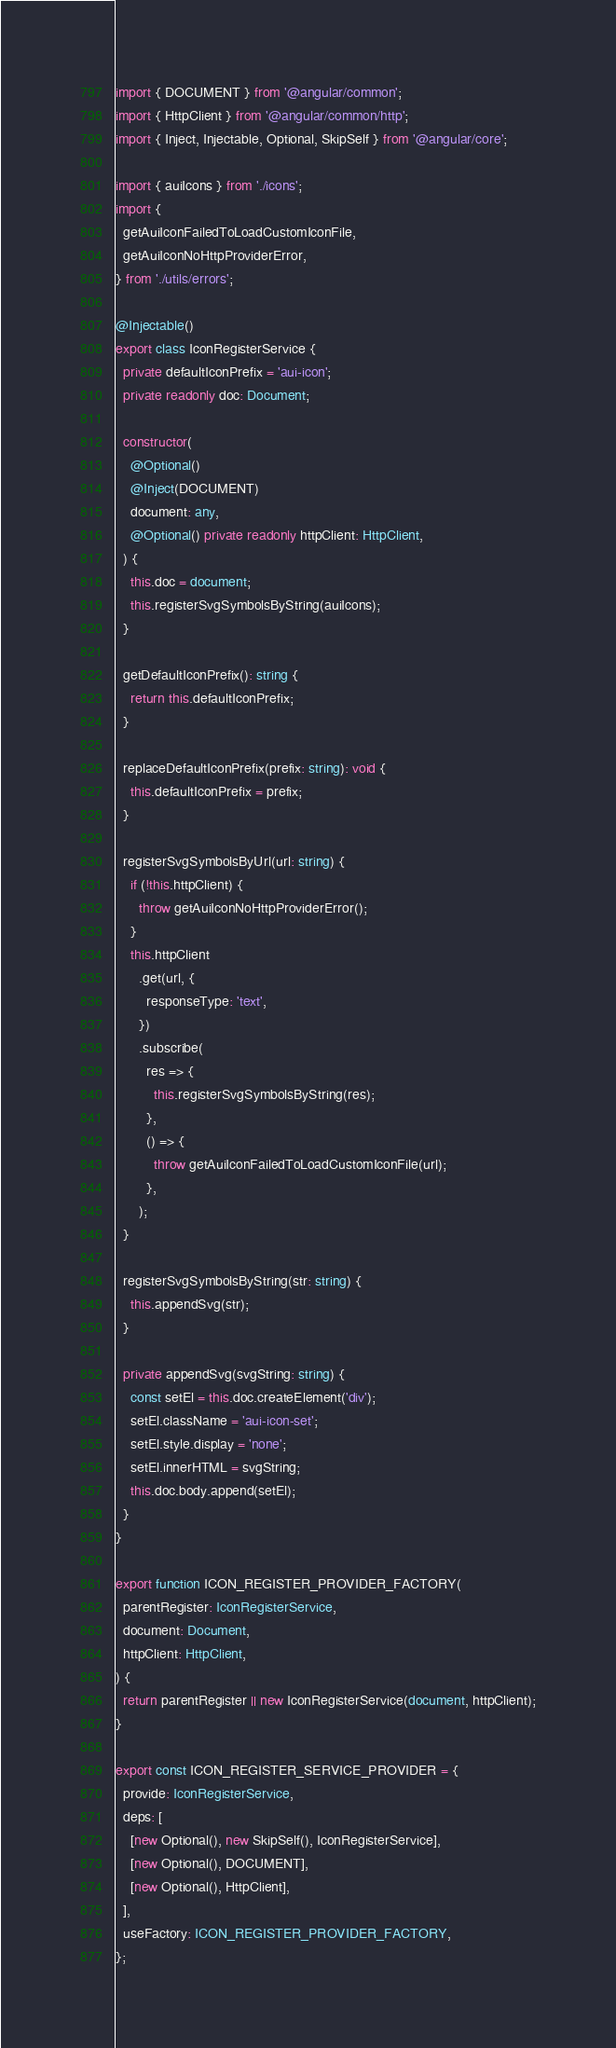<code> <loc_0><loc_0><loc_500><loc_500><_TypeScript_>import { DOCUMENT } from '@angular/common';
import { HttpClient } from '@angular/common/http';
import { Inject, Injectable, Optional, SkipSelf } from '@angular/core';

import { auiIcons } from './icons';
import {
  getAuiIconFailedToLoadCustomIconFile,
  getAuiIconNoHttpProviderError,
} from './utils/errors';

@Injectable()
export class IconRegisterService {
  private defaultIconPrefix = 'aui-icon';
  private readonly doc: Document;

  constructor(
    @Optional()
    @Inject(DOCUMENT)
    document: any,
    @Optional() private readonly httpClient: HttpClient,
  ) {
    this.doc = document;
    this.registerSvgSymbolsByString(auiIcons);
  }

  getDefaultIconPrefix(): string {
    return this.defaultIconPrefix;
  }

  replaceDefaultIconPrefix(prefix: string): void {
    this.defaultIconPrefix = prefix;
  }

  registerSvgSymbolsByUrl(url: string) {
    if (!this.httpClient) {
      throw getAuiIconNoHttpProviderError();
    }
    this.httpClient
      .get(url, {
        responseType: 'text',
      })
      .subscribe(
        res => {
          this.registerSvgSymbolsByString(res);
        },
        () => {
          throw getAuiIconFailedToLoadCustomIconFile(url);
        },
      );
  }

  registerSvgSymbolsByString(str: string) {
    this.appendSvg(str);
  }

  private appendSvg(svgString: string) {
    const setEl = this.doc.createElement('div');
    setEl.className = 'aui-icon-set';
    setEl.style.display = 'none';
    setEl.innerHTML = svgString;
    this.doc.body.append(setEl);
  }
}

export function ICON_REGISTER_PROVIDER_FACTORY(
  parentRegister: IconRegisterService,
  document: Document,
  httpClient: HttpClient,
) {
  return parentRegister || new IconRegisterService(document, httpClient);
}

export const ICON_REGISTER_SERVICE_PROVIDER = {
  provide: IconRegisterService,
  deps: [
    [new Optional(), new SkipSelf(), IconRegisterService],
    [new Optional(), DOCUMENT],
    [new Optional(), HttpClient],
  ],
  useFactory: ICON_REGISTER_PROVIDER_FACTORY,
};
</code> 